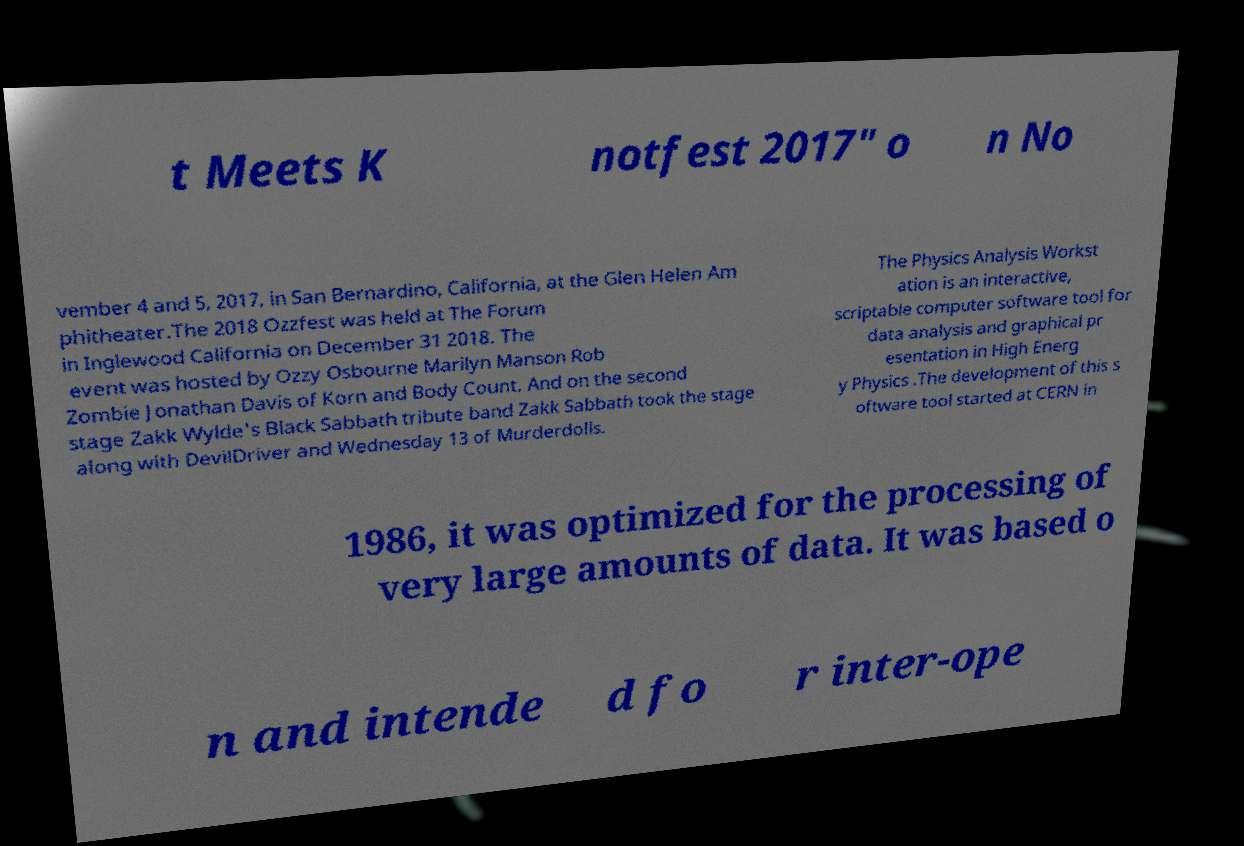Can you accurately transcribe the text from the provided image for me? t Meets K notfest 2017" o n No vember 4 and 5, 2017, in San Bernardino, California, at the Glen Helen Am phitheater.The 2018 Ozzfest was held at The Forum in Inglewood California on December 31 2018. The event was hosted by Ozzy Osbourne Marilyn Manson Rob Zombie Jonathan Davis of Korn and Body Count. And on the second stage Zakk Wylde's Black Sabbath tribute band Zakk Sabbath took the stage along with DevilDriver and Wednesday 13 of Murderdolls. The Physics Analysis Workst ation is an interactive, scriptable computer software tool for data analysis and graphical pr esentation in High Energ y Physics .The development of this s oftware tool started at CERN in 1986, it was optimized for the processing of very large amounts of data. It was based o n and intende d fo r inter-ope 